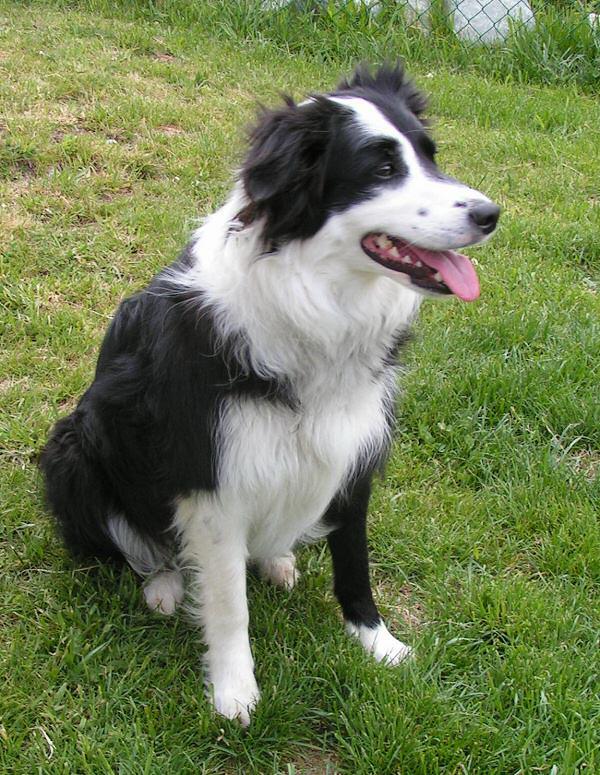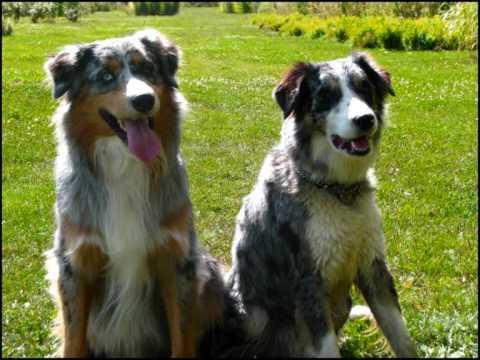The first image is the image on the left, the second image is the image on the right. Analyze the images presented: Is the assertion "There are exactly two dogs in the image on the right." valid? Answer yes or no. Yes. 